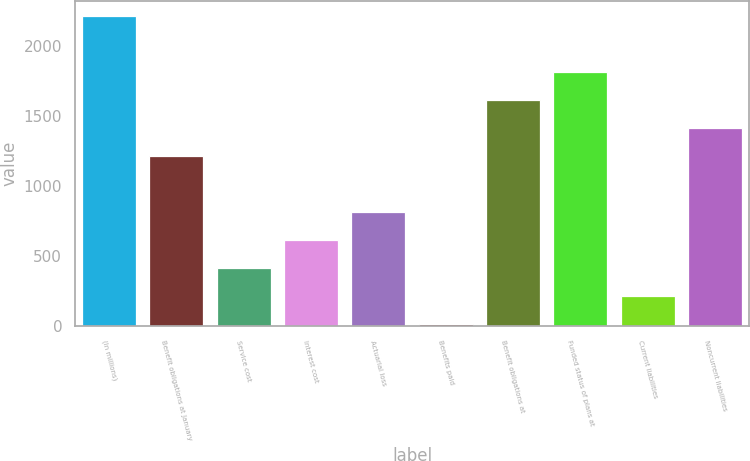Convert chart to OTSL. <chart><loc_0><loc_0><loc_500><loc_500><bar_chart><fcel>(In millions)<fcel>Benefit obligations at January<fcel>Service cost<fcel>Interest cost<fcel>Actuarial loss<fcel>Benefits paid<fcel>Benefit obligations at<fcel>Funded status of plans at<fcel>Current liabilities<fcel>Noncurrent liabilities<nl><fcel>2210.4<fcel>1213.4<fcel>415.8<fcel>615.2<fcel>814.6<fcel>17<fcel>1612.2<fcel>1811.6<fcel>216.4<fcel>1412.8<nl></chart> 